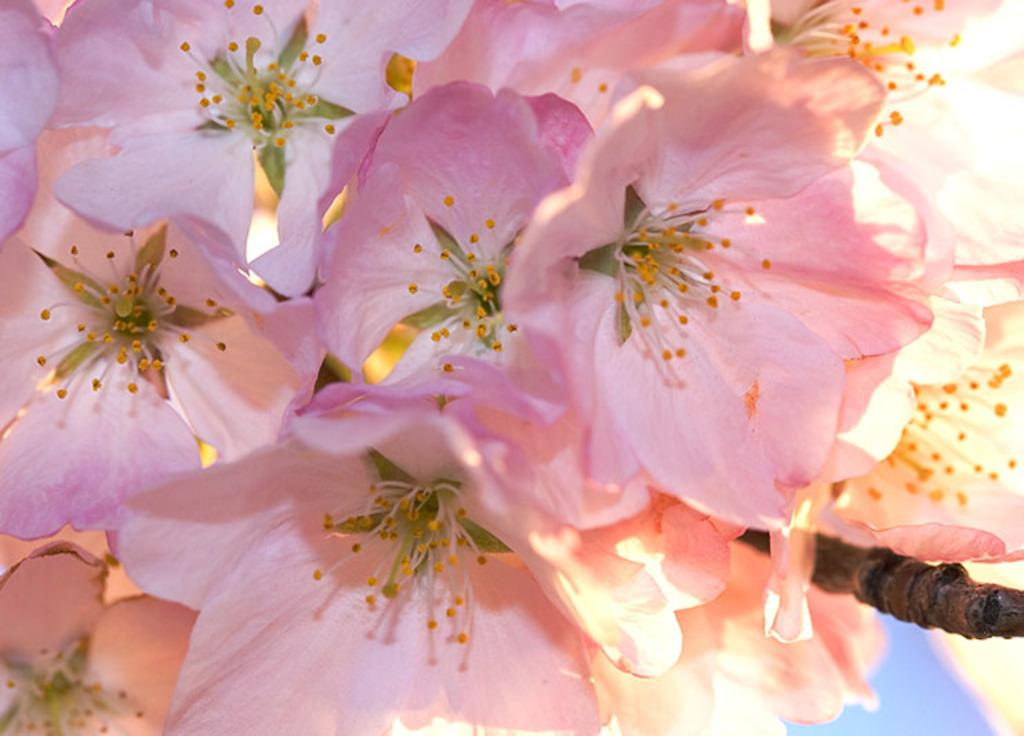What type of flowers can be seen in the image? There are pink color flowers in the image. Is there a spy hiding behind the flowers in the image? There is no indication of a spy or any hidden figure in the image; it only features pink color flowers. 